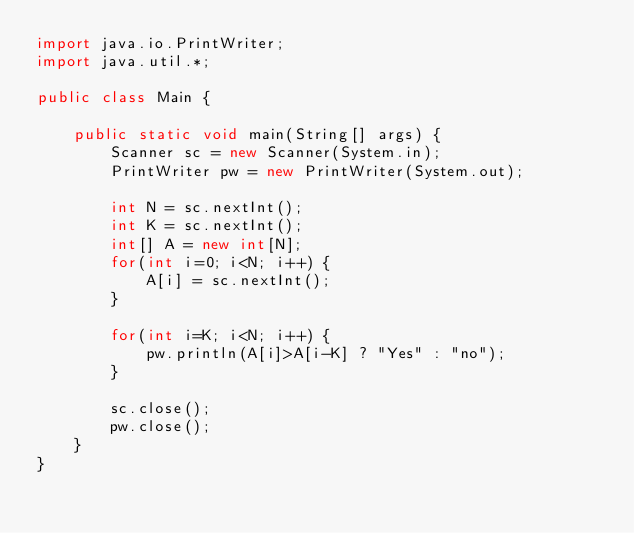Convert code to text. <code><loc_0><loc_0><loc_500><loc_500><_Java_>import java.io.PrintWriter;
import java.util.*;

public class Main {

	public static void main(String[] args) {
		Scanner sc = new Scanner(System.in);
		PrintWriter pw = new PrintWriter(System.out);
		
		int N = sc.nextInt();
		int K = sc.nextInt();
		int[] A = new int[N];
		for(int i=0; i<N; i++) {
			A[i] = sc.nextInt();
		}

		for(int i=K; i<N; i++) {
			pw.println(A[i]>A[i-K] ? "Yes" : "no");
		}
		
		sc.close();
		pw.close();
	}
}
</code> 